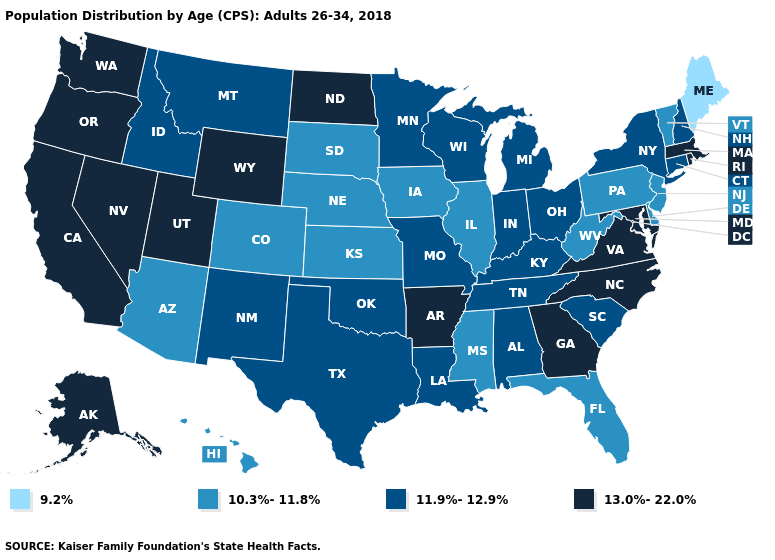What is the value of Illinois?
Short answer required. 10.3%-11.8%. Does the first symbol in the legend represent the smallest category?
Short answer required. Yes. Name the states that have a value in the range 10.3%-11.8%?
Answer briefly. Arizona, Colorado, Delaware, Florida, Hawaii, Illinois, Iowa, Kansas, Mississippi, Nebraska, New Jersey, Pennsylvania, South Dakota, Vermont, West Virginia. Name the states that have a value in the range 10.3%-11.8%?
Answer briefly. Arizona, Colorado, Delaware, Florida, Hawaii, Illinois, Iowa, Kansas, Mississippi, Nebraska, New Jersey, Pennsylvania, South Dakota, Vermont, West Virginia. What is the value of Utah?
Be succinct. 13.0%-22.0%. Name the states that have a value in the range 11.9%-12.9%?
Quick response, please. Alabama, Connecticut, Idaho, Indiana, Kentucky, Louisiana, Michigan, Minnesota, Missouri, Montana, New Hampshire, New Mexico, New York, Ohio, Oklahoma, South Carolina, Tennessee, Texas, Wisconsin. Does Georgia have a lower value than North Carolina?
Concise answer only. No. How many symbols are there in the legend?
Concise answer only. 4. What is the lowest value in states that border New York?
Keep it brief. 10.3%-11.8%. Name the states that have a value in the range 10.3%-11.8%?
Concise answer only. Arizona, Colorado, Delaware, Florida, Hawaii, Illinois, Iowa, Kansas, Mississippi, Nebraska, New Jersey, Pennsylvania, South Dakota, Vermont, West Virginia. Among the states that border Wisconsin , does Michigan have the highest value?
Be succinct. Yes. Which states hav the highest value in the West?
Be succinct. Alaska, California, Nevada, Oregon, Utah, Washington, Wyoming. What is the lowest value in the West?
Short answer required. 10.3%-11.8%. Name the states that have a value in the range 9.2%?
Be succinct. Maine. Does the map have missing data?
Answer briefly. No. 